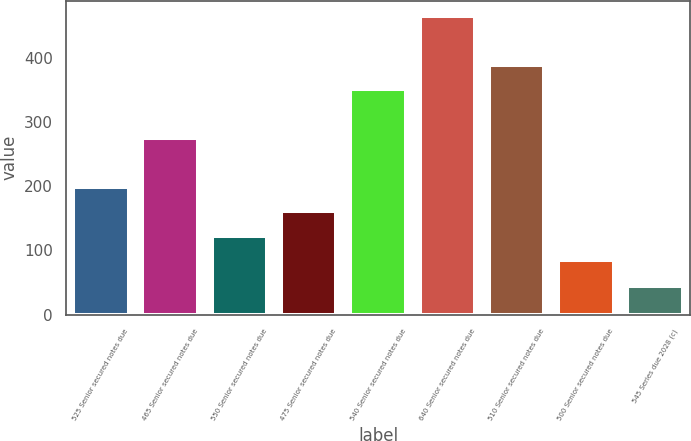Convert chart. <chart><loc_0><loc_0><loc_500><loc_500><bar_chart><fcel>525 Senior secured notes due<fcel>465 Senior secured notes due<fcel>550 Senior secured notes due<fcel>475 Senior secured notes due<fcel>540 Senior secured notes due<fcel>640 Senior secured notes due<fcel>510 Senior secured notes due<fcel>500 Senior secured notes due<fcel>545 Series due 2028 (c)<nl><fcel>199.3<fcel>275.5<fcel>123.1<fcel>161.2<fcel>351.7<fcel>466<fcel>389.8<fcel>85<fcel>44<nl></chart> 